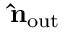Convert formula to latex. <formula><loc_0><loc_0><loc_500><loc_500>\hat { n } _ { o u t }</formula> 